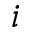Convert formula to latex. <formula><loc_0><loc_0><loc_500><loc_500>i</formula> 